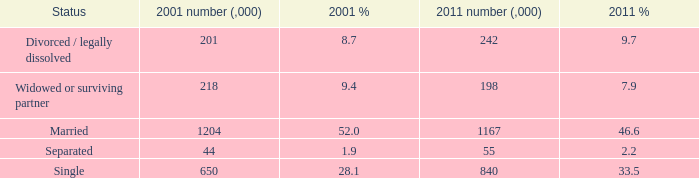What is the 2001 % for the status widowed or surviving partner? 9.4. 